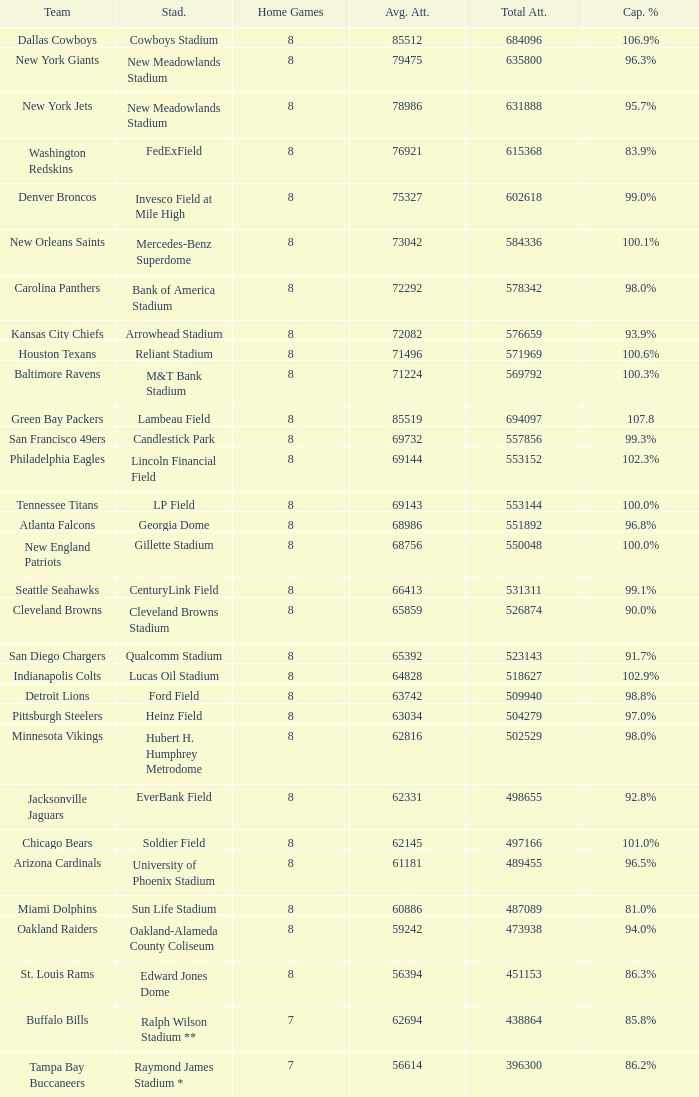What is the name of the team when the stadium is listed as Edward Jones Dome? St. Louis Rams. 